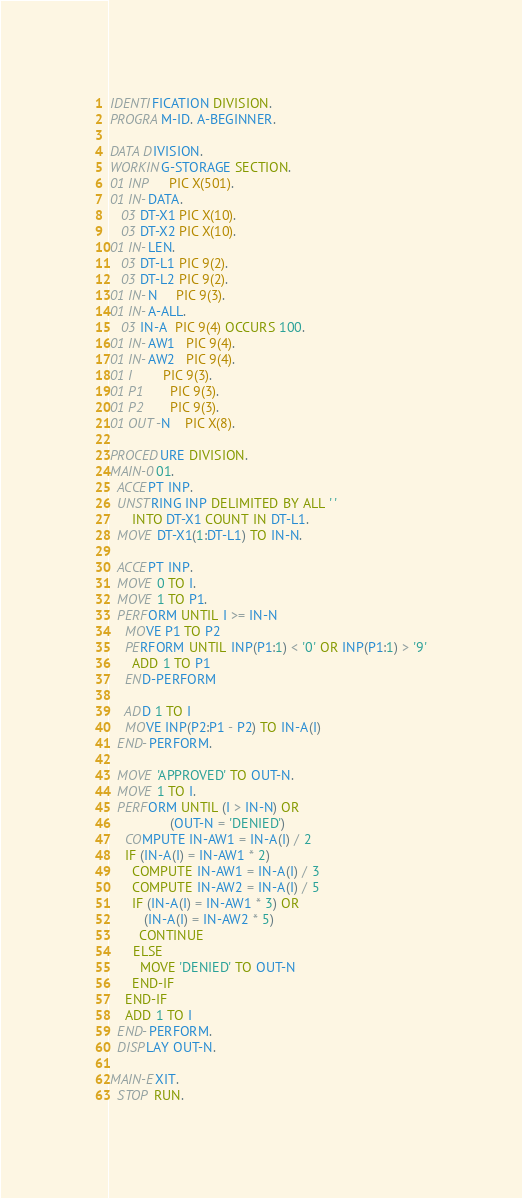<code> <loc_0><loc_0><loc_500><loc_500><_COBOL_>IDENTIFICATION DIVISION.
PROGRAM-ID. A-BEGINNER.

DATA DIVISION.
WORKING-STORAGE SECTION.
01 INP     PIC X(501).
01 IN-DATA.
   03 DT-X1 PIC X(10).
   03 DT-X2 PIC X(10).
01 IN-LEN.
   03 DT-L1 PIC 9(2).
   03 DT-L2 PIC 9(2).
01 IN-N     PIC 9(3).
01 IN-A-ALL.
   03 IN-A  PIC 9(4) OCCURS 100.
01 IN-AW1   PIC 9(4).
01 IN-AW2   PIC 9(4).
01 I        PIC 9(3).
01 P1       PIC 9(3).
01 P2       PIC 9(3).
01 OUT-N    PIC X(8).

PROCEDURE DIVISION.
MAIN-001.
  ACCEPT INP.
  UNSTRING INP DELIMITED BY ALL ' '
      INTO DT-X1 COUNT IN DT-L1.
  MOVE DT-X1(1:DT-L1) TO IN-N.

  ACCEPT INP.
  MOVE 0 TO I.
  MOVE 1 TO P1.
  PERFORM UNTIL I >= IN-N
    MOVE P1 TO P2
    PERFORM UNTIL INP(P1:1) < '0' OR INP(P1:1) > '9'
      ADD 1 TO P1
    END-PERFORM

    ADD 1 TO I
    MOVE INP(P2:P1 - P2) TO IN-A(I)
  END-PERFORM.

  MOVE 'APPROVED' TO OUT-N.
  MOVE 1 TO I.
  PERFORM UNTIL (I > IN-N) OR
                (OUT-N = 'DENIED')
    COMPUTE IN-AW1 = IN-A(I) / 2
    IF (IN-A(I) = IN-AW1 * 2)
      COMPUTE IN-AW1 = IN-A(I) / 3
      COMPUTE IN-AW2 = IN-A(I) / 5
      IF (IN-A(I) = IN-AW1 * 3) OR
         (IN-A(I) = IN-AW2 * 5)
        CONTINUE
      ELSE
        MOVE 'DENIED' TO OUT-N
      END-IF
    END-IF
    ADD 1 TO I  
  END-PERFORM.
  DISPLAY OUT-N.

MAIN-EXIT.
  STOP RUN.
</code> 